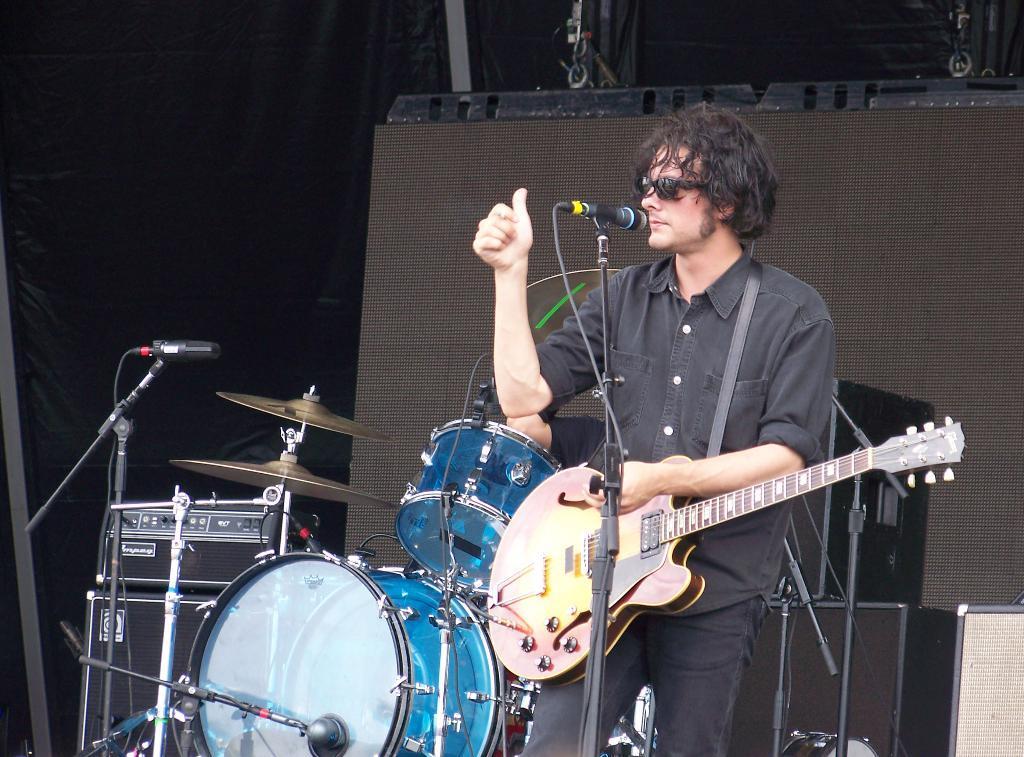Describe this image in one or two sentences. In this picture we can see a man, he wore spectacles, in front of him we can see few musical instruments and microphones, in the background we can see few speakers. 